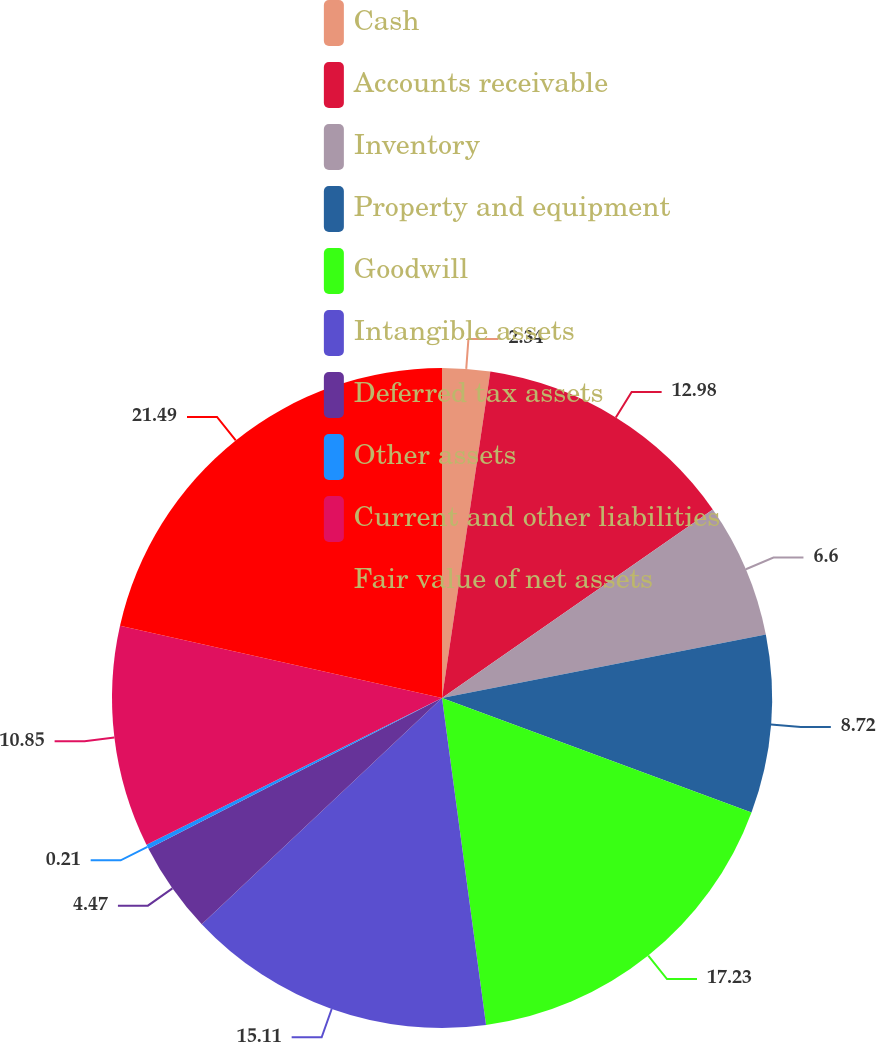Convert chart. <chart><loc_0><loc_0><loc_500><loc_500><pie_chart><fcel>Cash<fcel>Accounts receivable<fcel>Inventory<fcel>Property and equipment<fcel>Goodwill<fcel>Intangible assets<fcel>Deferred tax assets<fcel>Other assets<fcel>Current and other liabilities<fcel>Fair value of net assets<nl><fcel>2.34%<fcel>12.98%<fcel>6.6%<fcel>8.72%<fcel>17.23%<fcel>15.11%<fcel>4.47%<fcel>0.21%<fcel>10.85%<fcel>21.49%<nl></chart> 